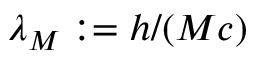Convert formula to latex. <formula><loc_0><loc_0><loc_500><loc_500>\lambda _ { M } \colon = h / ( M c )</formula> 